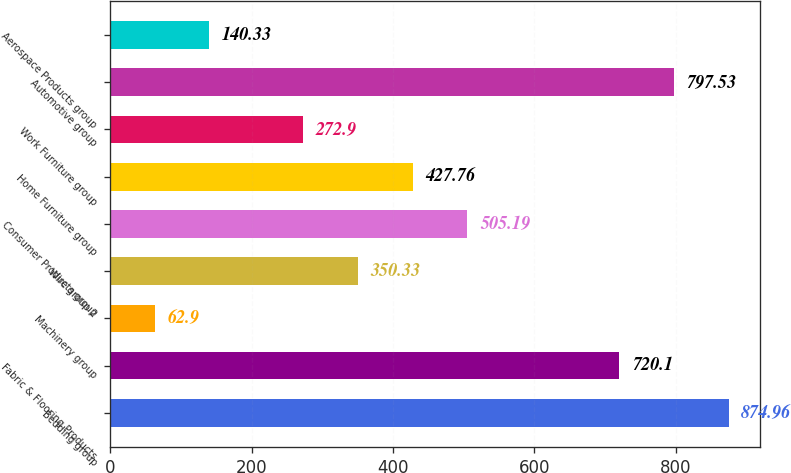<chart> <loc_0><loc_0><loc_500><loc_500><bar_chart><fcel>Bedding group<fcel>Fabric & Flooring Products<fcel>Machinery group<fcel>Wire group 2<fcel>Consumer Products group<fcel>Home Furniture group<fcel>Work Furniture group<fcel>Automotive group<fcel>Aerospace Products group<nl><fcel>874.96<fcel>720.1<fcel>62.9<fcel>350.33<fcel>505.19<fcel>427.76<fcel>272.9<fcel>797.53<fcel>140.33<nl></chart> 